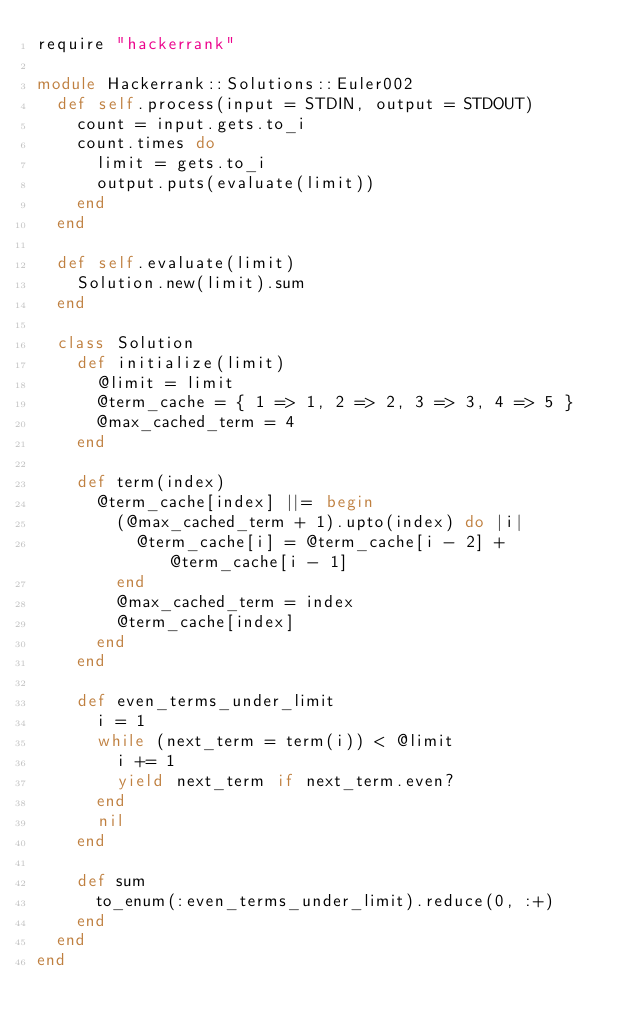Convert code to text. <code><loc_0><loc_0><loc_500><loc_500><_Ruby_>require "hackerrank"

module Hackerrank::Solutions::Euler002
  def self.process(input = STDIN, output = STDOUT)
    count = input.gets.to_i
    count.times do
      limit = gets.to_i
      output.puts(evaluate(limit))
    end
  end

  def self.evaluate(limit)
    Solution.new(limit).sum
  end

  class Solution
    def initialize(limit)
      @limit = limit
      @term_cache = { 1 => 1, 2 => 2, 3 => 3, 4 => 5 }
      @max_cached_term = 4
    end

    def term(index)
      @term_cache[index] ||= begin
        (@max_cached_term + 1).upto(index) do |i|
          @term_cache[i] = @term_cache[i - 2] + @term_cache[i - 1]
        end
        @max_cached_term = index
        @term_cache[index]
      end
    end

    def even_terms_under_limit
      i = 1
      while (next_term = term(i)) < @limit
        i += 1
        yield next_term if next_term.even?
      end
      nil
    end

    def sum
      to_enum(:even_terms_under_limit).reduce(0, :+)
    end
  end
end
</code> 